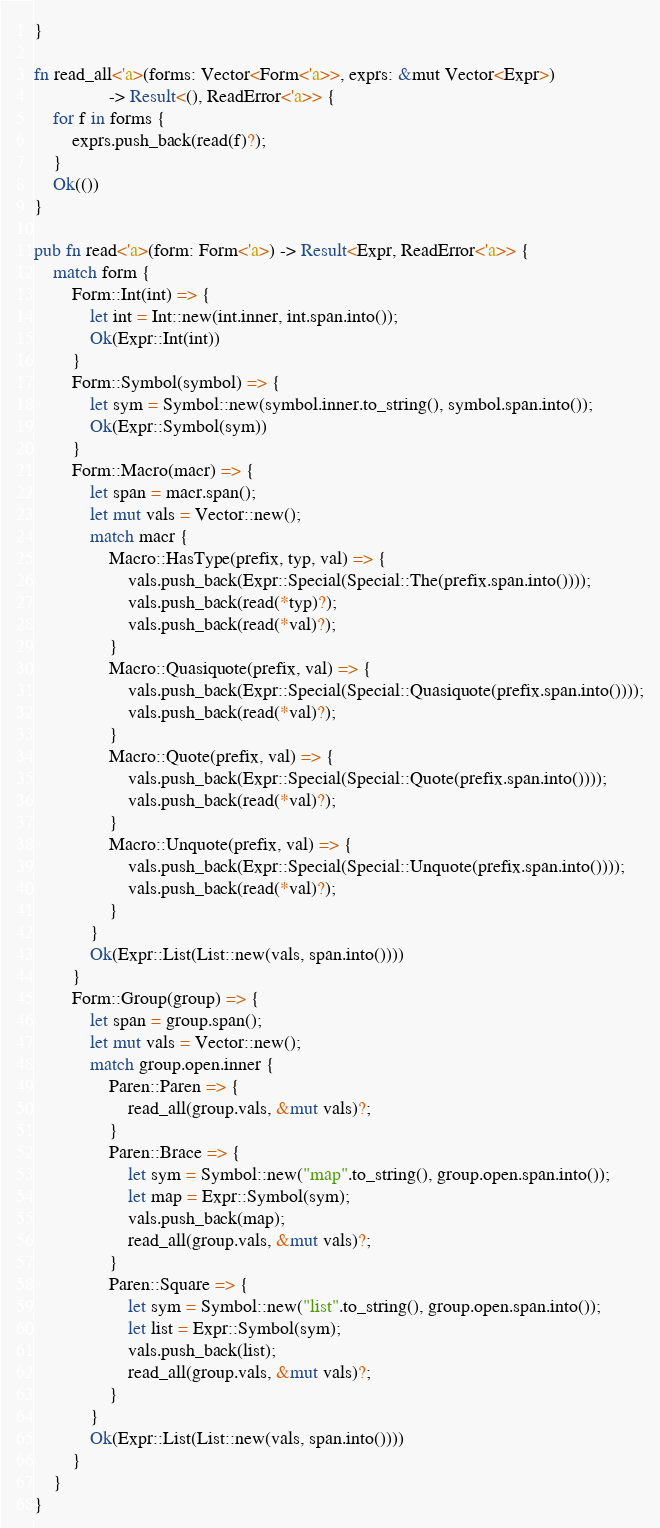<code> <loc_0><loc_0><loc_500><loc_500><_Rust_>}

fn read_all<'a>(forms: Vector<Form<'a>>, exprs: &mut Vector<Expr>)
                -> Result<(), ReadError<'a>> {
    for f in forms {
        exprs.push_back(read(f)?);
    }
    Ok(())
}

pub fn read<'a>(form: Form<'a>) -> Result<Expr, ReadError<'a>> {
    match form {
        Form::Int(int) => {
            let int = Int::new(int.inner, int.span.into());
            Ok(Expr::Int(int))
        }
        Form::Symbol(symbol) => {
            let sym = Symbol::new(symbol.inner.to_string(), symbol.span.into());
            Ok(Expr::Symbol(sym))
        }
        Form::Macro(macr) => {
            let span = macr.span();
            let mut vals = Vector::new();
            match macr {
                Macro::HasType(prefix, typ, val) => {
                    vals.push_back(Expr::Special(Special::The(prefix.span.into())));
                    vals.push_back(read(*typ)?);                    
                    vals.push_back(read(*val)?);
                }
                Macro::Quasiquote(prefix, val) => {
                    vals.push_back(Expr::Special(Special::Quasiquote(prefix.span.into())));
                    vals.push_back(read(*val)?);
                }
                Macro::Quote(prefix, val) => {
                    vals.push_back(Expr::Special(Special::Quote(prefix.span.into())));
                    vals.push_back(read(*val)?);
                }
                Macro::Unquote(prefix, val) => {
                    vals.push_back(Expr::Special(Special::Unquote(prefix.span.into())));
                    vals.push_back(read(*val)?);
                }
            }
            Ok(Expr::List(List::new(vals, span.into())))
        }
        Form::Group(group) => {
            let span = group.span();
            let mut vals = Vector::new();
            match group.open.inner {
                Paren::Paren => {
                    read_all(group.vals, &mut vals)?;
                }
                Paren::Brace => {
                    let sym = Symbol::new("map".to_string(), group.open.span.into());
                    let map = Expr::Symbol(sym);
                    vals.push_back(map);
                    read_all(group.vals, &mut vals)?;
                }
                Paren::Square => {
                    let sym = Symbol::new("list".to_string(), group.open.span.into());
                    let list = Expr::Symbol(sym);
                    vals.push_back(list);
                    read_all(group.vals, &mut vals)?;
                }
            }
            Ok(Expr::List(List::new(vals, span.into())))
        }
    }
}
</code> 